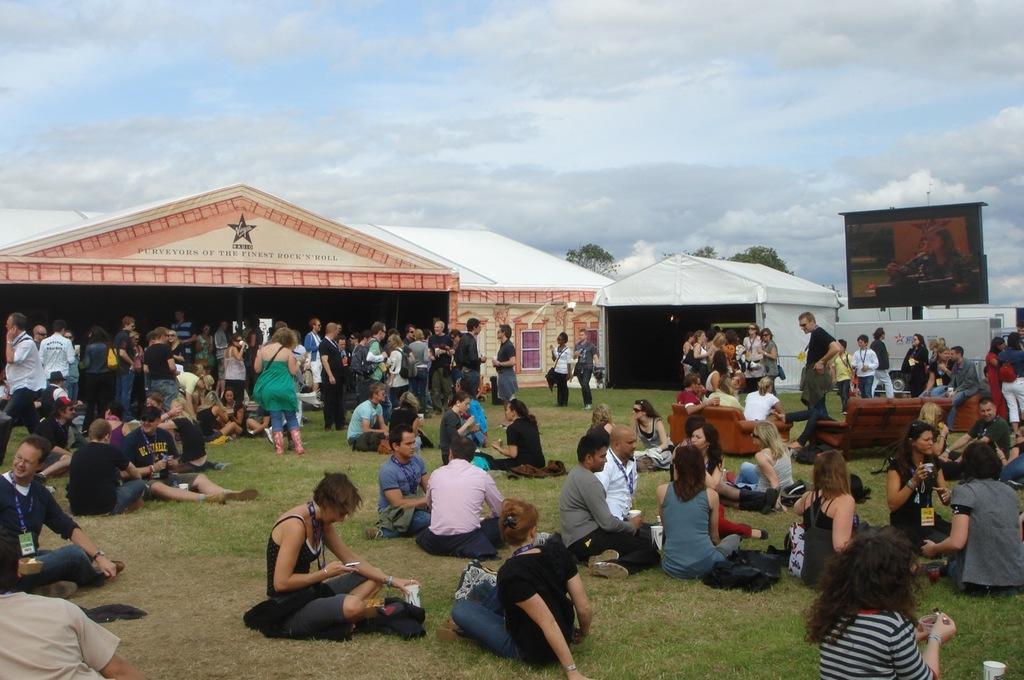What is the condition of the sky in the image? The sky is cloudy in the image. What are the people in the image doing? There are people sitting on the grass in the image. What type of structures can be seen in the image? There are sheds in the image. What is the purpose of the screen in the image? The purpose of the screen is not clear from the image, but it could be used for displaying information or as a barrier. What type of vegetation is present in the image? There are trees in the image. What type of furniture is visible in the image? There are couches in the image. Can you hear the robin singing in the image? There is no robin present in the image, so it is not possible to hear it singing. Is the grass covered in sleet in the image? The image does not show any sleet; the sky is cloudy, but the grass appears to be dry. How many times does the person on the left sneeze in the image? There is no indication of anyone sneezing in the image. 